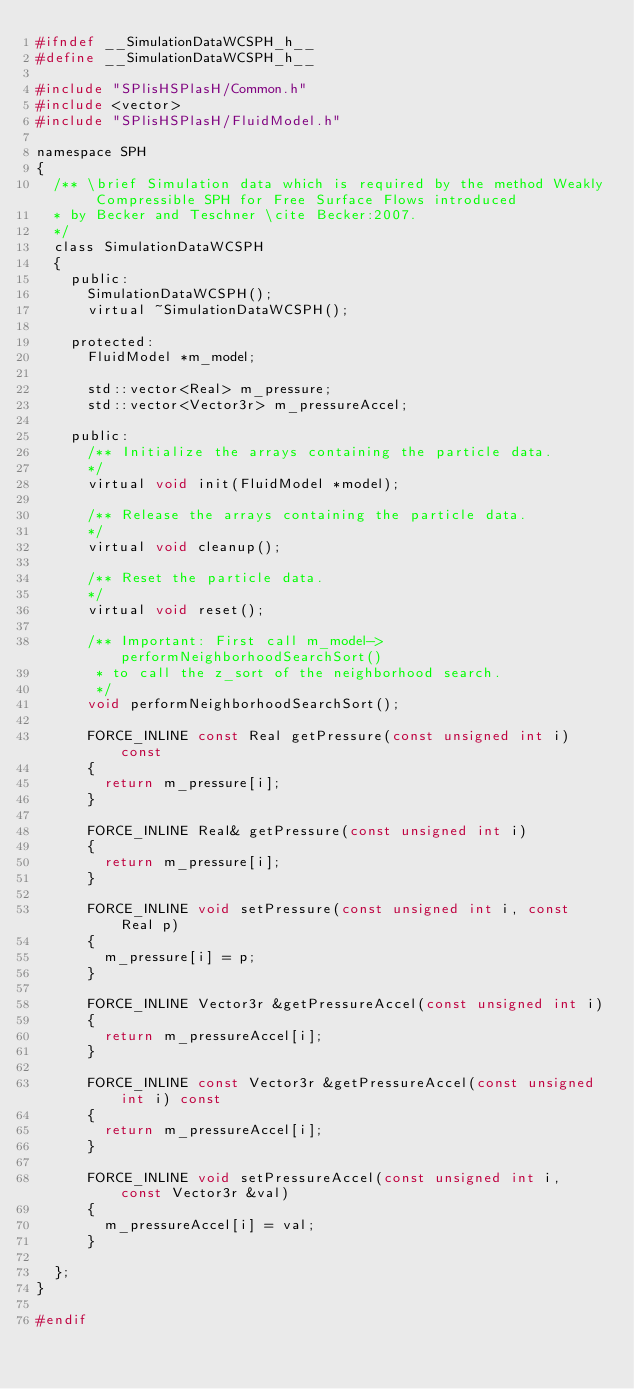<code> <loc_0><loc_0><loc_500><loc_500><_C_>#ifndef __SimulationDataWCSPH_h__
#define __SimulationDataWCSPH_h__

#include "SPlisHSPlasH/Common.h"
#include <vector>
#include "SPlisHSPlasH/FluidModel.h"

namespace SPH 
{	
	/** \brief Simulation data which is required by the method Weakly Compressible SPH for Free Surface Flows introduced
	* by Becker and Teschner \cite Becker:2007.
	*/
	class SimulationDataWCSPH
	{
		public:
			SimulationDataWCSPH();
			virtual ~SimulationDataWCSPH();

		protected:	
			FluidModel *m_model;

			std::vector<Real> m_pressure;
			std::vector<Vector3r> m_pressureAccel;

		public:
			/** Initialize the arrays containing the particle data.
			*/
			virtual void init(FluidModel *model);
			
			/** Release the arrays containing the particle data.
			*/
			virtual void cleanup();

			/** Reset the particle data.
			*/
			virtual void reset();

			/** Important: First call m_model->performNeighborhoodSearchSort() 
			 * to call the z_sort of the neighborhood search.
			 */
			void performNeighborhoodSearchSort();

			FORCE_INLINE const Real getPressure(const unsigned int i) const
			{
				return m_pressure[i];
			}

			FORCE_INLINE Real& getPressure(const unsigned int i)
			{
				return m_pressure[i];
			}

			FORCE_INLINE void setPressure(const unsigned int i, const Real p)
			{
				m_pressure[i] = p;
			}

			FORCE_INLINE Vector3r &getPressureAccel(const unsigned int i)
			{
				return m_pressureAccel[i];
			}

			FORCE_INLINE const Vector3r &getPressureAccel(const unsigned int i) const
			{
				return m_pressureAccel[i];
			}

			FORCE_INLINE void setPressureAccel(const unsigned int i, const Vector3r &val)
			{
				m_pressureAccel[i] = val;
			}

	};
}

#endif</code> 